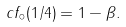<formula> <loc_0><loc_0><loc_500><loc_500>c f _ { \circ } ( 1 / 4 ) = 1 - \beta .</formula> 